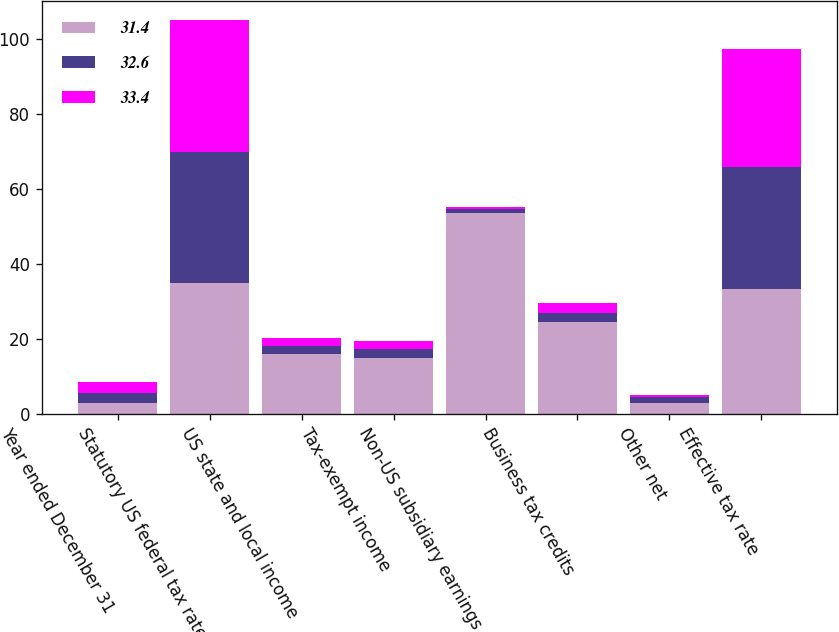<chart> <loc_0><loc_0><loc_500><loc_500><stacked_bar_chart><ecel><fcel>Year ended December 31<fcel>Statutory US federal tax rate<fcel>US state and local income<fcel>Tax-exempt income<fcel>Non-US subsidiary earnings<fcel>Business tax credits<fcel>Other net<fcel>Effective tax rate<nl><fcel>31.4<fcel>2.8<fcel>35<fcel>16<fcel>14.8<fcel>53.6<fcel>24.5<fcel>2.8<fcel>33.4<nl><fcel>32.6<fcel>2.8<fcel>35<fcel>2<fcel>2.4<fcel>1.1<fcel>2.5<fcel>1.6<fcel>32.6<nl><fcel>33.4<fcel>2.8<fcel>35<fcel>2.1<fcel>2.2<fcel>0.5<fcel>2.5<fcel>0.5<fcel>31.4<nl></chart> 